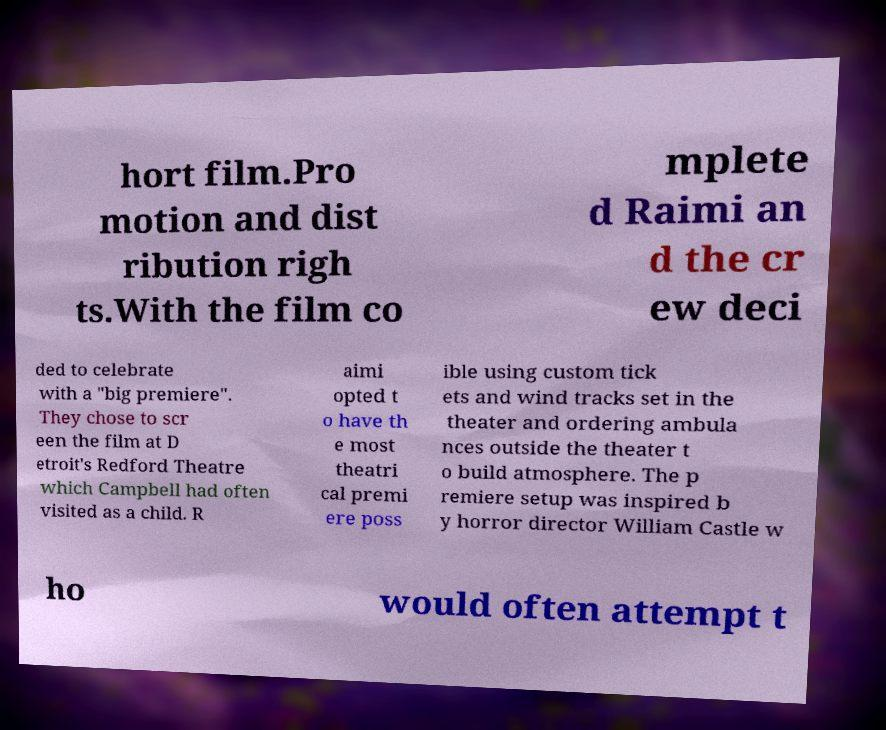There's text embedded in this image that I need extracted. Can you transcribe it verbatim? hort film.Pro motion and dist ribution righ ts.With the film co mplete d Raimi an d the cr ew deci ded to celebrate with a "big premiere". They chose to scr een the film at D etroit's Redford Theatre which Campbell had often visited as a child. R aimi opted t o have th e most theatri cal premi ere poss ible using custom tick ets and wind tracks set in the theater and ordering ambula nces outside the theater t o build atmosphere. The p remiere setup was inspired b y horror director William Castle w ho would often attempt t 